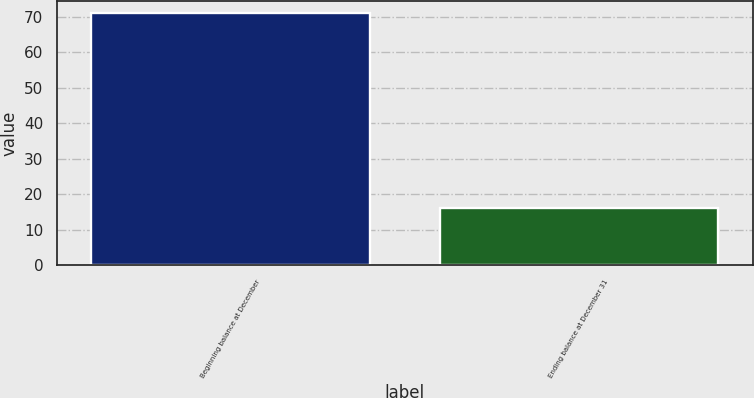Convert chart to OTSL. <chart><loc_0><loc_0><loc_500><loc_500><bar_chart><fcel>Beginning balance at December<fcel>Ending balance at December 31<nl><fcel>71<fcel>16<nl></chart> 